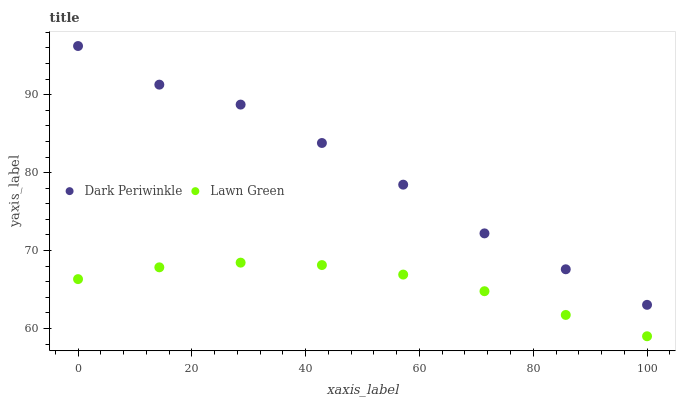Does Lawn Green have the minimum area under the curve?
Answer yes or no. Yes. Does Dark Periwinkle have the maximum area under the curve?
Answer yes or no. Yes. Does Dark Periwinkle have the minimum area under the curve?
Answer yes or no. No. Is Lawn Green the smoothest?
Answer yes or no. Yes. Is Dark Periwinkle the roughest?
Answer yes or no. Yes. Is Dark Periwinkle the smoothest?
Answer yes or no. No. Does Lawn Green have the lowest value?
Answer yes or no. Yes. Does Dark Periwinkle have the lowest value?
Answer yes or no. No. Does Dark Periwinkle have the highest value?
Answer yes or no. Yes. Is Lawn Green less than Dark Periwinkle?
Answer yes or no. Yes. Is Dark Periwinkle greater than Lawn Green?
Answer yes or no. Yes. Does Lawn Green intersect Dark Periwinkle?
Answer yes or no. No. 